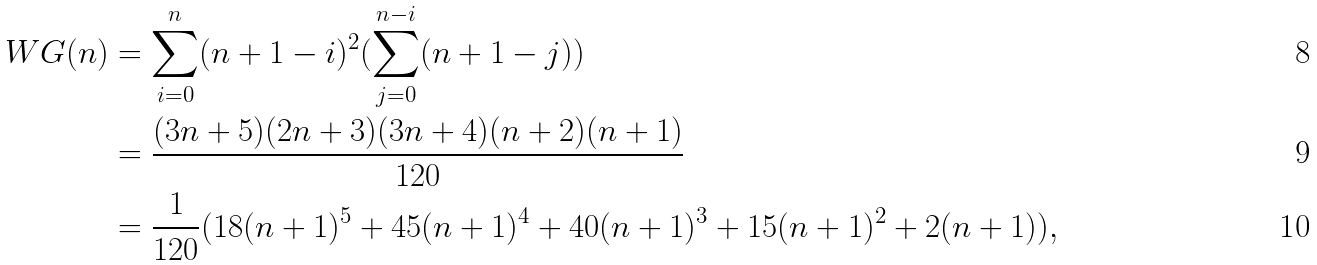Convert formula to latex. <formula><loc_0><loc_0><loc_500><loc_500>W G ( n ) & = \sum _ { i = 0 } ^ { n } ( n + 1 - i ) ^ { 2 } ( \sum _ { j = 0 } ^ { n - i } ( n + 1 - j ) ) \\ & = \frac { ( 3 n + 5 ) ( 2 n + 3 ) ( 3 n + 4 ) ( n + 2 ) ( n + 1 ) } { 1 2 0 } \\ & = \frac { 1 } { 1 2 0 } ( 1 8 ( n + 1 ) ^ { 5 } + 4 5 ( n + 1 ) ^ { 4 } + 4 0 ( n + 1 ) ^ { 3 } + 1 5 ( n + 1 ) ^ { 2 } + 2 ( n + 1 ) ) ,</formula> 